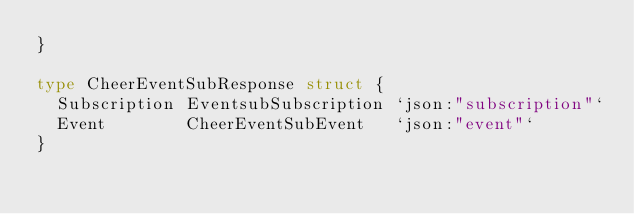<code> <loc_0><loc_0><loc_500><loc_500><_Go_>}

type CheerEventSubResponse struct {
	Subscription EventsubSubscription `json:"subscription"`
	Event        CheerEventSubEvent   `json:"event"`
}
</code> 